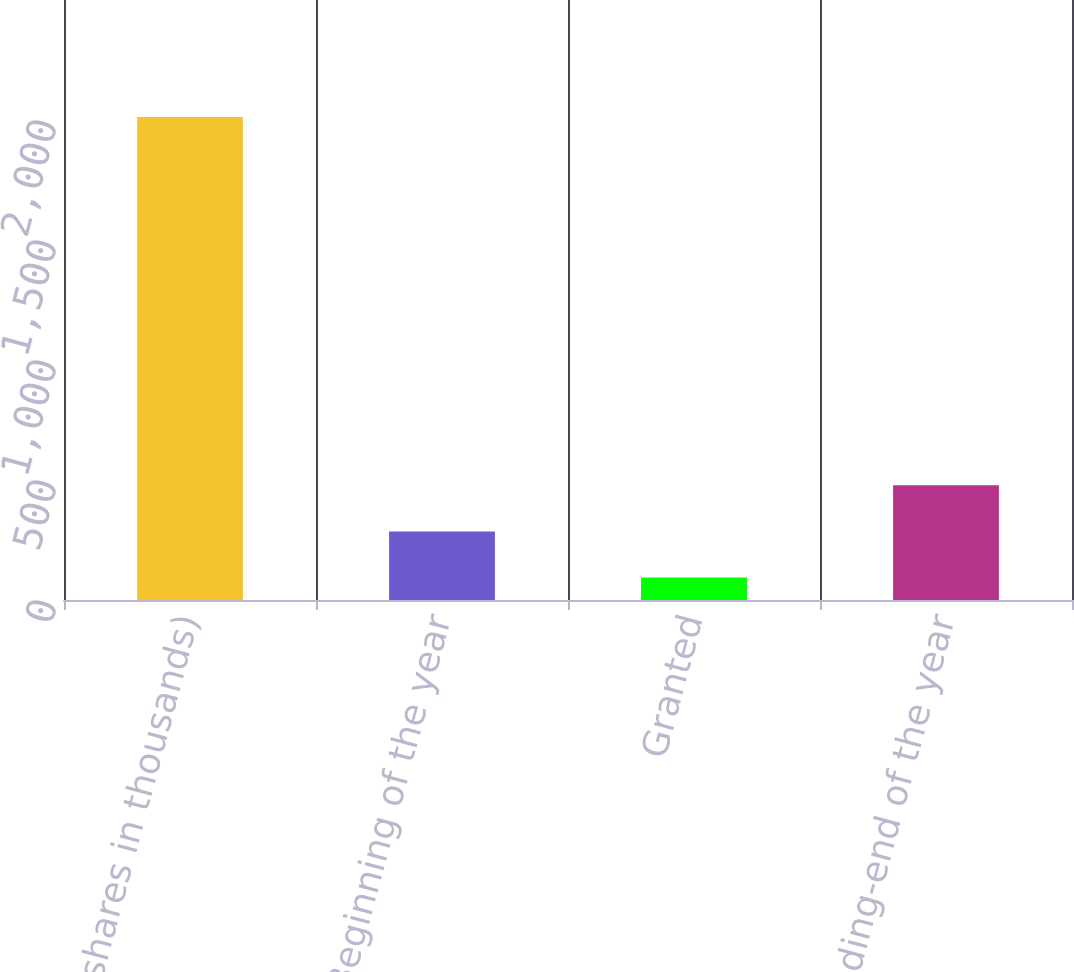<chart> <loc_0><loc_0><loc_500><loc_500><bar_chart><fcel>(shares in thousands)<fcel>Beginning of the year<fcel>Granted<fcel>Outstanding-end of the year<nl><fcel>2013<fcel>285.9<fcel>94<fcel>477.8<nl></chart> 